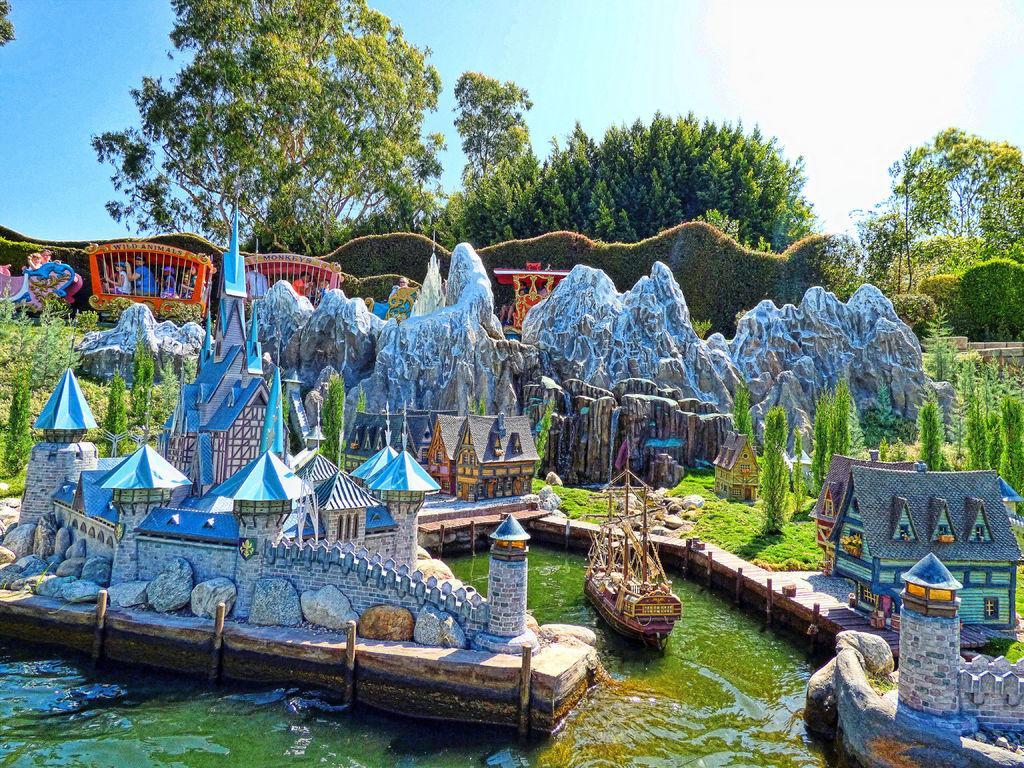In one or two sentences, can you explain what this image depicts? In this image there is a miniature kingdom and the image consists of boats and also water. In the background there are many trees and also a grass wall as fence. At the top there is sky. 